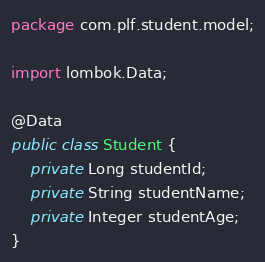Convert code to text. <code><loc_0><loc_0><loc_500><loc_500><_Java_>package com.plf.student.model;

import lombok.Data;

@Data
public class Student {
    private Long studentId;
    private String studentName;
    private Integer studentAge;
}
</code> 